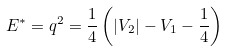<formula> <loc_0><loc_0><loc_500><loc_500>E ^ { * } = q ^ { 2 } = \frac { 1 } { 4 } \left ( | V _ { 2 } | - V _ { 1 } - \frac { 1 } { 4 } \right )</formula> 